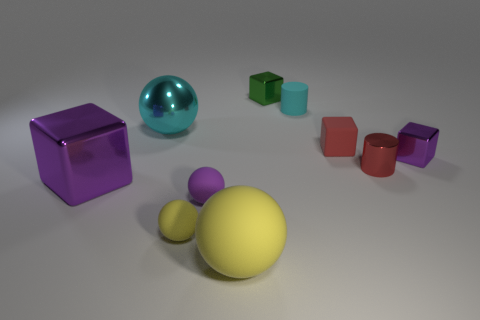Subtract all red blocks. How many blocks are left? 3 Subtract 3 spheres. How many spheres are left? 1 Subtract all cyan cylinders. How many yellow spheres are left? 2 Subtract all yellow balls. How many balls are left? 2 Subtract all green metal things. Subtract all small cyan rubber cylinders. How many objects are left? 8 Add 1 tiny purple matte balls. How many tiny purple matte balls are left? 2 Add 1 big purple metallic things. How many big purple metallic things exist? 2 Subtract 0 yellow blocks. How many objects are left? 10 Subtract all cubes. How many objects are left? 6 Subtract all red cylinders. Subtract all yellow spheres. How many cylinders are left? 1 